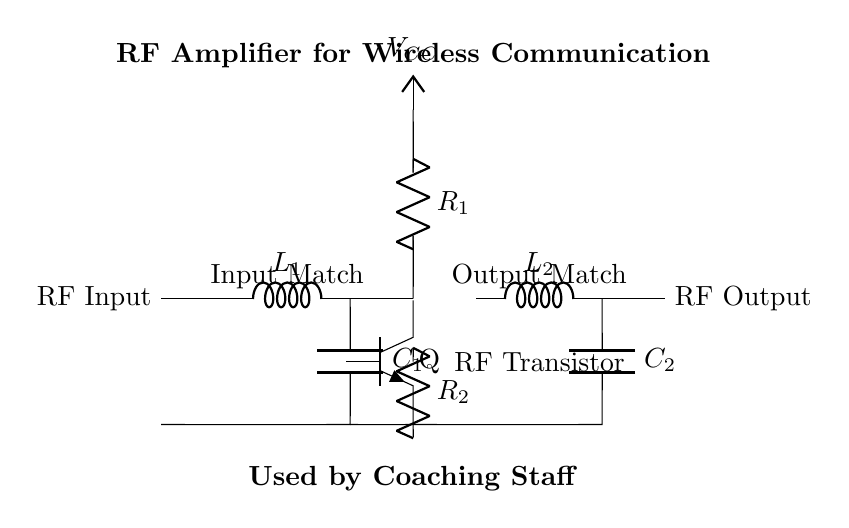What is the input of this circuit? The input of the circuit is labeled as RF Input, which is the point where the radio frequency signal enters before being amplified.
Answer: RF Input What is the output component of this amplifier? The output component of the amplifier is labeled as RF Output, where the amplified signal is sent out after passing through the output network.
Answer: RF Output How many inductors are present in the circuit? There are two inductors present in the circuit, labeled as L1 and L2, which are parts of the matching networks for input and output.
Answer: 2 What is the function of the transistor in this circuit? The function of the transistor, marked as Q, is to amplify the RF signal; it is the core component that provides gain to the circuit.
Answer: Amplification What is the power supply voltage? The power supply voltage is denoted as VCC, and while a specific numerical value is not provided in the circuit diagram, it is essential for the operation of the amplifier.
Answer: VCC Which network is used to match the input and output? The circuit employs matching networks, specifically labeled as Input Match and Output Match, which consist of the inductors and capacitors to adjust impedance levels for optimal signal transfer.
Answer: Matching networks 